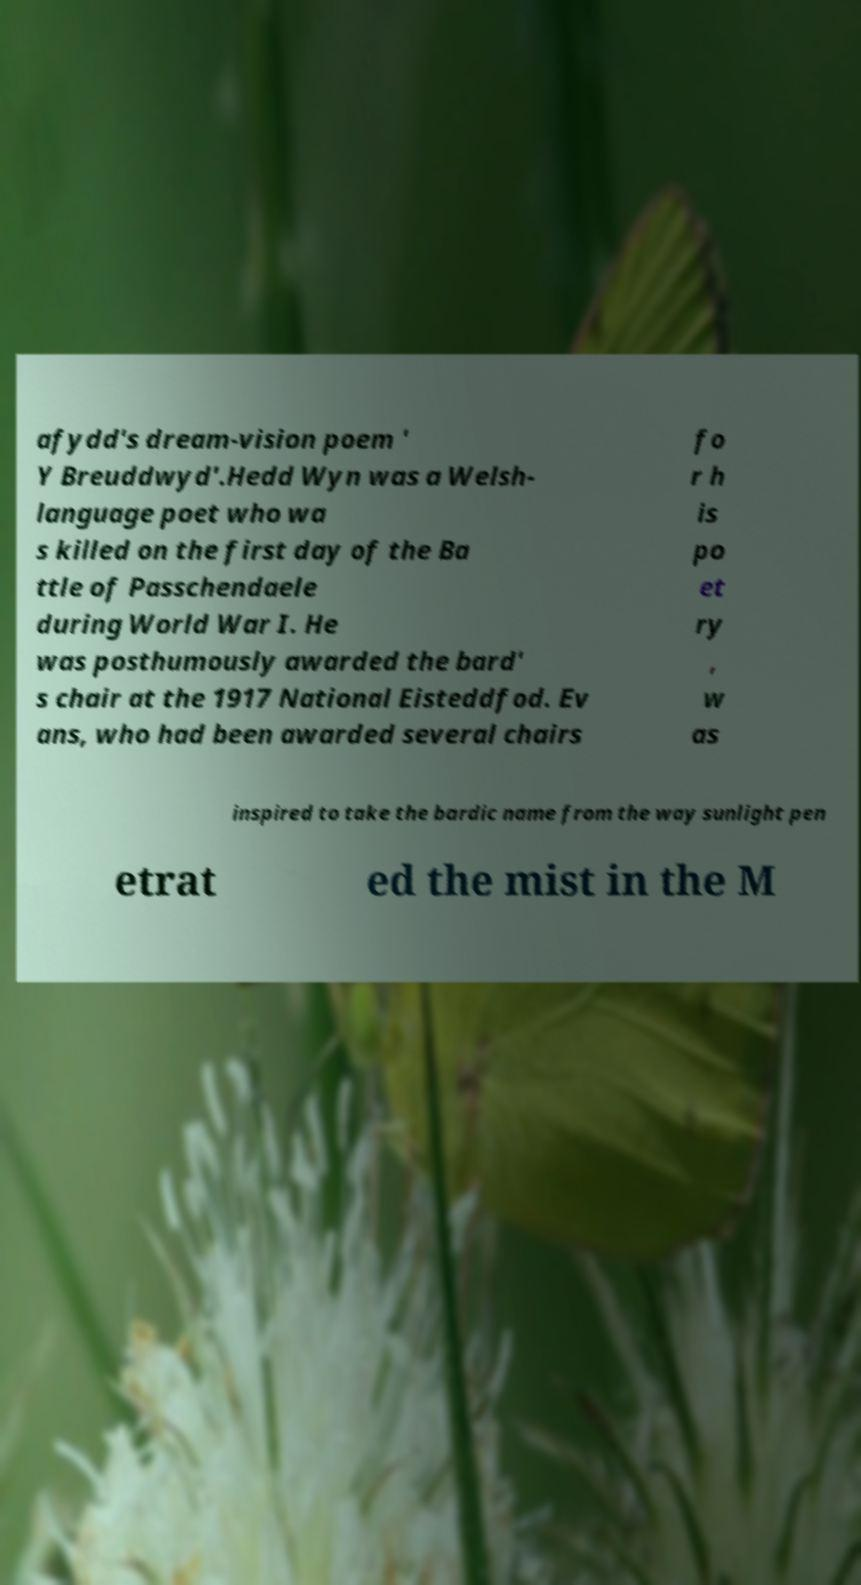I need the written content from this picture converted into text. Can you do that? afydd's dream-vision poem ' Y Breuddwyd'.Hedd Wyn was a Welsh- language poet who wa s killed on the first day of the Ba ttle of Passchendaele during World War I. He was posthumously awarded the bard' s chair at the 1917 National Eisteddfod. Ev ans, who had been awarded several chairs fo r h is po et ry , w as inspired to take the bardic name from the way sunlight pen etrat ed the mist in the M 